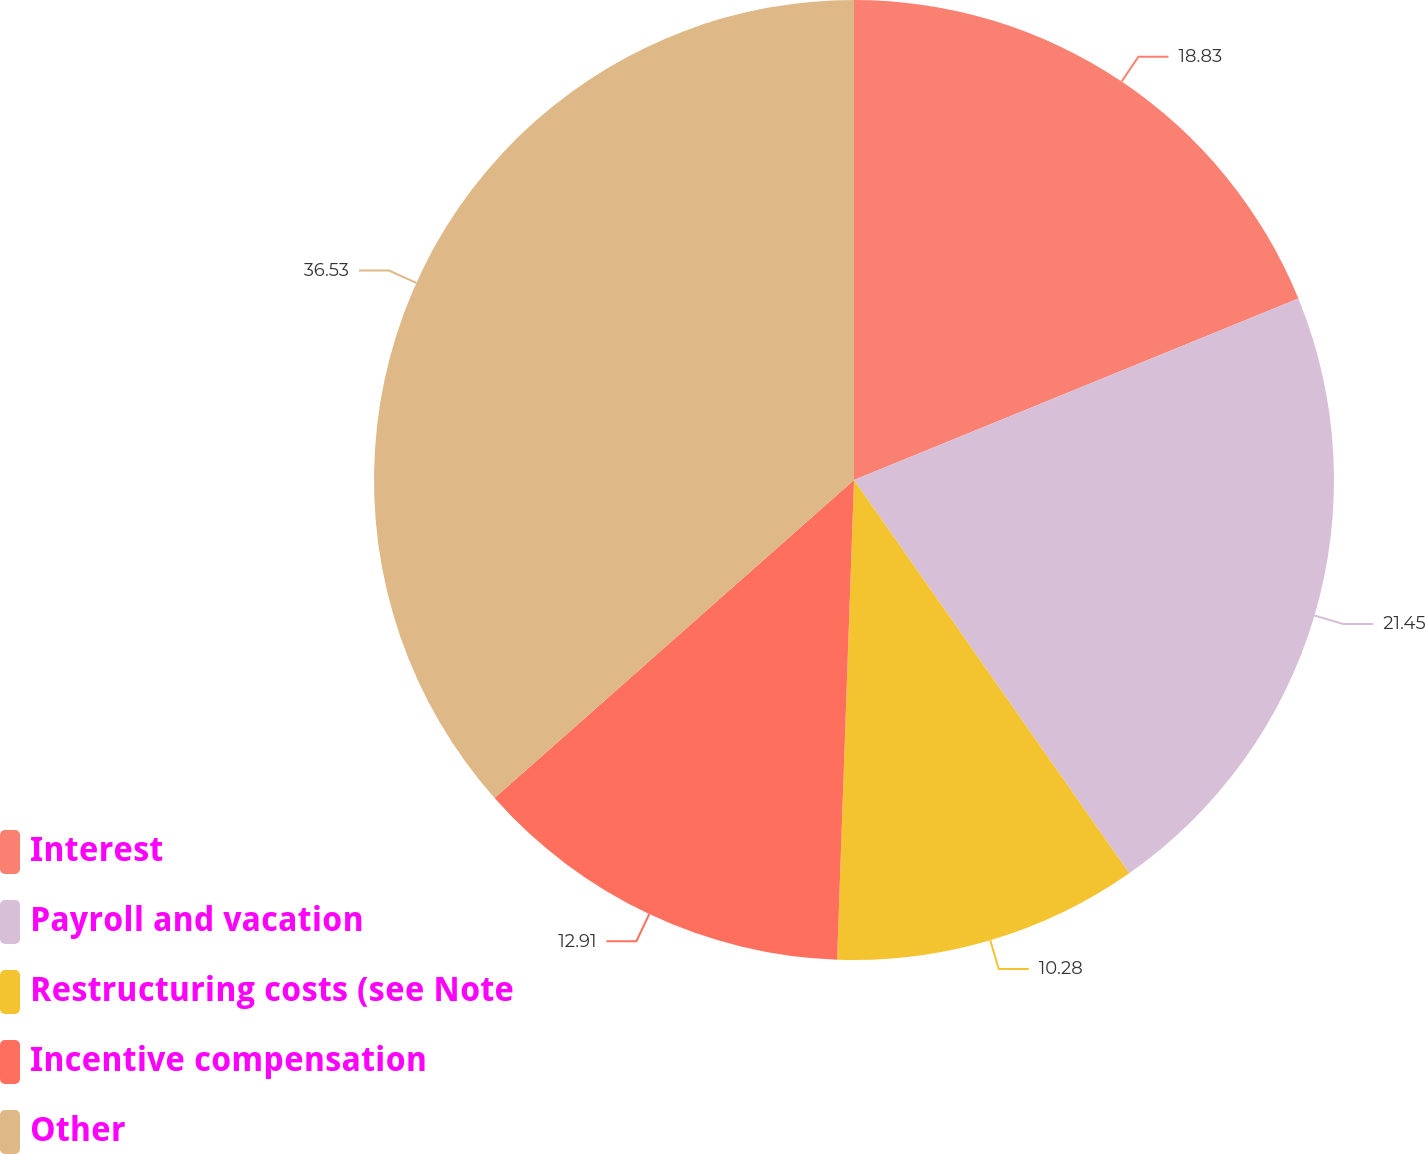Convert chart. <chart><loc_0><loc_0><loc_500><loc_500><pie_chart><fcel>Interest<fcel>Payroll and vacation<fcel>Restructuring costs (see Note<fcel>Incentive compensation<fcel>Other<nl><fcel>18.83%<fcel>21.45%<fcel>10.28%<fcel>12.91%<fcel>36.53%<nl></chart> 